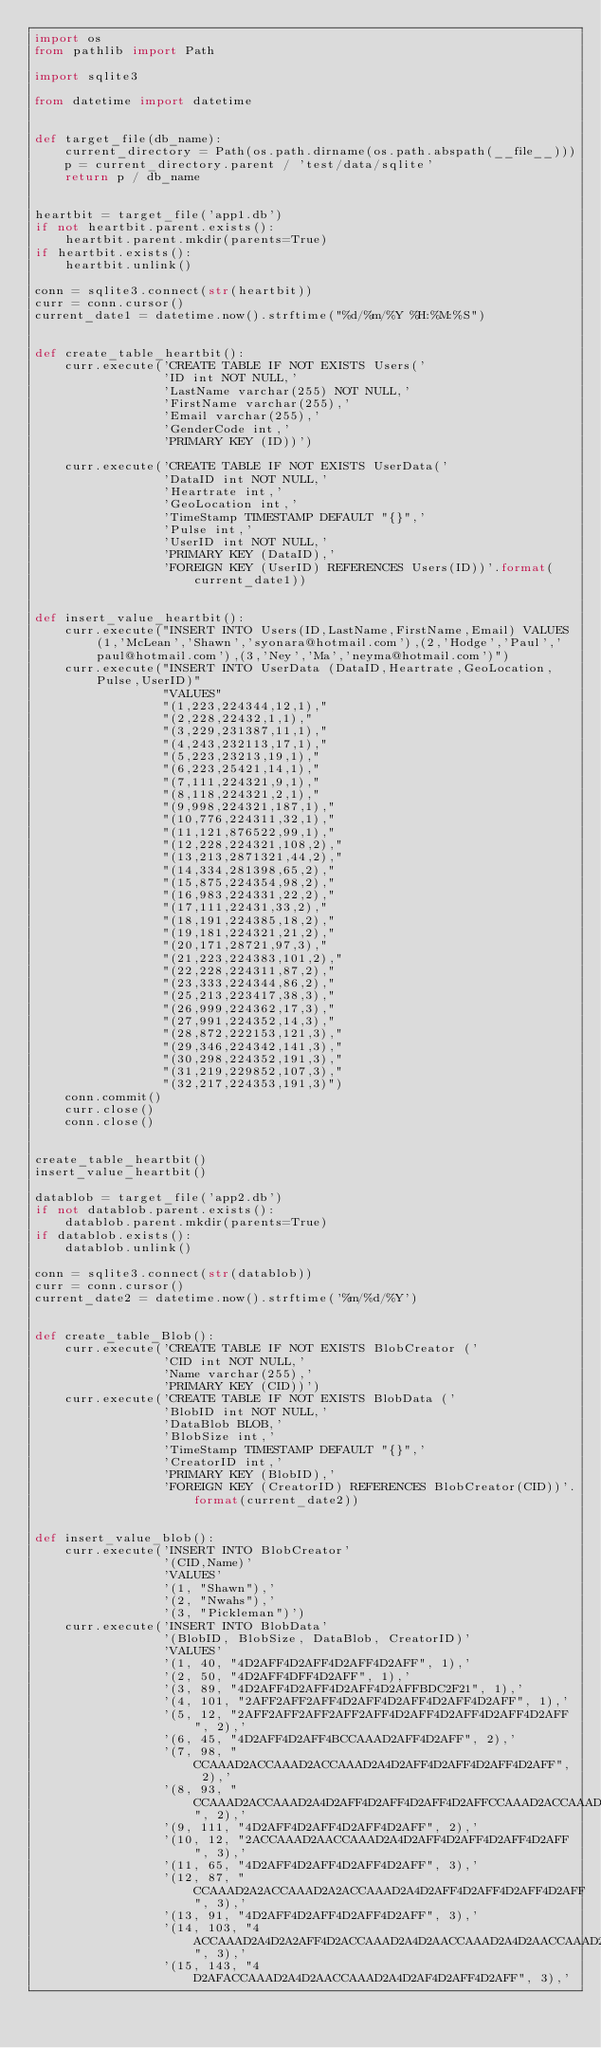Convert code to text. <code><loc_0><loc_0><loc_500><loc_500><_Python_>import os
from pathlib import Path

import sqlite3

from datetime import datetime


def target_file(db_name):
    current_directory = Path(os.path.dirname(os.path.abspath(__file__)))
    p = current_directory.parent / 'test/data/sqlite'
    return p / db_name


heartbit = target_file('app1.db')
if not heartbit.parent.exists():
    heartbit.parent.mkdir(parents=True)
if heartbit.exists():
    heartbit.unlink()

conn = sqlite3.connect(str(heartbit))
curr = conn.cursor()
current_date1 = datetime.now().strftime("%d/%m/%Y %H:%M:%S")


def create_table_heartbit():
    curr.execute('CREATE TABLE IF NOT EXISTS Users('
                 'ID int NOT NULL,'
                 'LastName varchar(255) NOT NULL,'
                 'FirstName varchar(255),'
                 'Email varchar(255),'
                 'GenderCode int,'
                 'PRIMARY KEY (ID))')

    curr.execute('CREATE TABLE IF NOT EXISTS UserData('
                 'DataID int NOT NULL,'
                 'Heartrate int,'
                 'GeoLocation int,'
                 'TimeStamp TIMESTAMP DEFAULT "{}",'
                 'Pulse int,'
                 'UserID int NOT NULL,'
                 'PRIMARY KEY (DataID),'
                 'FOREIGN KEY (UserID) REFERENCES Users(ID))'.format(current_date1))


def insert_value_heartbit():
    curr.execute("INSERT INTO Users(ID,LastName,FirstName,Email) VALUES (1,'McLean','Shawn','syonara@hotmail.com'),(2,'Hodge','Paul','paul@hotmail.com'),(3,'Ney','Ma','neyma@hotmail.com')")
    curr.execute("INSERT INTO UserData (DataID,Heartrate,GeoLocation,Pulse,UserID)"
                 "VALUES"
                 "(1,223,224344,12,1),"
                 "(2,228,22432,1,1),"
                 "(3,229,231387,11,1),"
                 "(4,243,232113,17,1),"
                 "(5,223,23213,19,1),"
                 "(6,223,25421,14,1),"
                 "(7,111,224321,9,1),"
                 "(8,118,224321,2,1),"
                 "(9,998,224321,187,1),"
                 "(10,776,224311,32,1),"
                 "(11,121,876522,99,1),"
                 "(12,228,224321,108,2),"
                 "(13,213,2871321,44,2),"
                 "(14,334,281398,65,2),"
                 "(15,875,224354,98,2),"
                 "(16,983,224331,22,2),"
                 "(17,111,22431,33,2),"
                 "(18,191,224385,18,2),"
                 "(19,181,224321,21,2),"
                 "(20,171,28721,97,3),"
                 "(21,223,224383,101,2),"
                 "(22,228,224311,87,2),"
                 "(23,333,224344,86,2),"
                 "(25,213,223417,38,3),"
                 "(26,999,224362,17,3),"
                 "(27,991,224352,14,3),"
                 "(28,872,222153,121,3),"
                 "(29,346,224342,141,3),"
                 "(30,298,224352,191,3),"
                 "(31,219,229852,107,3),"
                 "(32,217,224353,191,3)")
    conn.commit()
    curr.close()
    conn.close()


create_table_heartbit()
insert_value_heartbit()

datablob = target_file('app2.db')
if not datablob.parent.exists():
    datablob.parent.mkdir(parents=True)
if datablob.exists():
    datablob.unlink()

conn = sqlite3.connect(str(datablob))
curr = conn.cursor()
current_date2 = datetime.now().strftime('%m/%d/%Y')


def create_table_Blob():
    curr.execute('CREATE TABLE IF NOT EXISTS BlobCreator ('
                 'CID int NOT NULL,'
                 'Name varchar(255),'
                 'PRIMARY KEY (CID))')
    curr.execute('CREATE TABLE IF NOT EXISTS BlobData ('
                 'BlobID int NOT NULL,'
                 'DataBlob BLOB,'
                 'BlobSize int,'
                 'TimeStamp TIMESTAMP DEFAULT "{}",'
                 'CreatorID int,'
                 'PRIMARY KEY (BlobID),'
                 'FOREIGN KEY (CreatorID) REFERENCES BlobCreator(CID))'.format(current_date2))


def insert_value_blob():
    curr.execute('INSERT INTO BlobCreator'
                 '(CID,Name)'
                 'VALUES'
                 '(1, "Shawn"),' 
                 '(2, "Nwahs"),'
                 '(3, "Pickleman")')
    curr.execute('INSERT INTO BlobData'
                 '(BlobID, BlobSize, DataBlob, CreatorID)'
                 'VALUES'
                 '(1, 40, "4D2AFF4D2AFF4D2AFF4D2AFF", 1),'
                 '(2, 50, "4D2AFF4DFF4D2AFF", 1),'
                 '(3, 89, "4D2AFF4D2AFF4D2AFF4D2AFFBDC2F21", 1),'
                 '(4, 101, "2AFF2AFF2AFF4D2AFF4D2AFF4D2AFF4D2AFF", 1),'
                 '(5, 12, "2AFF2AFF2AFF2AFF2AFF4D2AFF4D2AFF4D2AFF4D2AFF", 2),'
                 '(6, 45, "4D2AFF4D2AFF4BCCAAAD2AFF4D2AFF", 2),'
                 '(7, 98, "CCAAAD2ACCAAAD2ACCAAAD2A4D2AFF4D2AFF4D2AFF4D2AFF", 2),'
                 '(8, 93, "CCAAAD2ACCAAAD2A4D2AFF4D2AFF4D2AFF4D2AFFCCAAAD2ACCAAAD2A", 2),'
                 '(9, 111, "4D2AFF4D2AFF4D2AFF4D2AFF", 2),'
                 '(10, 12, "2ACCAAAD2AACCAAAD2A4D2AFF4D2AFF4D2AFF4D2AFF", 3),'
                 '(11, 65, "4D2AFF4D2AFF4D2AFF4D2AFF", 3),'
                 '(12, 87, "CCAAAD2A2ACCAAAD2A2ACCAAAD2A4D2AFF4D2AFF4D2AFF4D2AFF", 3),'
                 '(13, 91, "4D2AFF4D2AFF4D2AFF4D2AFF", 3),'
                 '(14, 103, "4ACCAAAD2A4D2A2AFF4D2ACCAAAD2A4D2AACCAAAD2A4D2AACCAAAD2A4D2A2AFF", 3),'
                 '(15, 143, "4D2AFACCAAAD2A4D2AACCAAAD2A4D2AF4D2AFF4D2AFF", 3),'</code> 